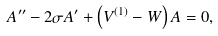<formula> <loc_0><loc_0><loc_500><loc_500>A ^ { \prime \prime } - 2 \sigma A ^ { \prime } + \left ( V ^ { ( 1 ) } - W \right ) A = 0 ,</formula> 